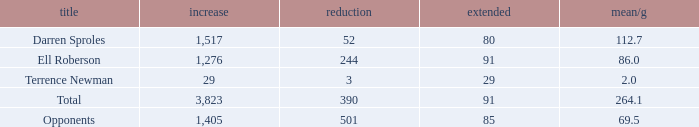When the player gained below 1,405 yards and lost over 390 yards, what's the sum of the long yards? None. 